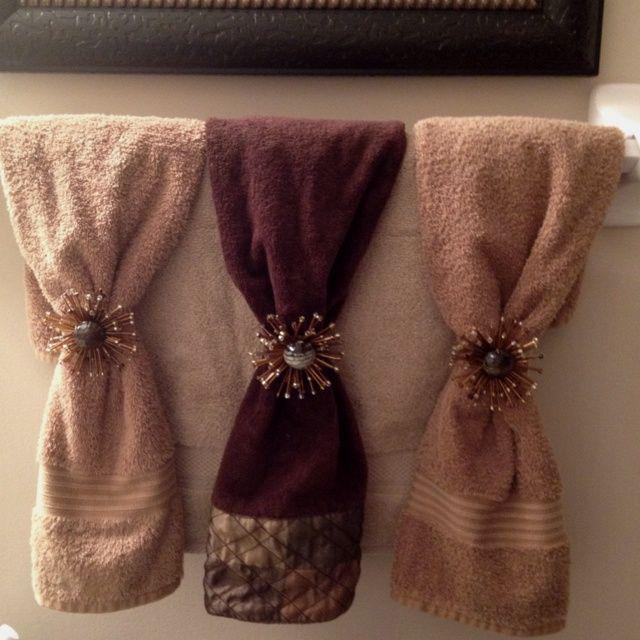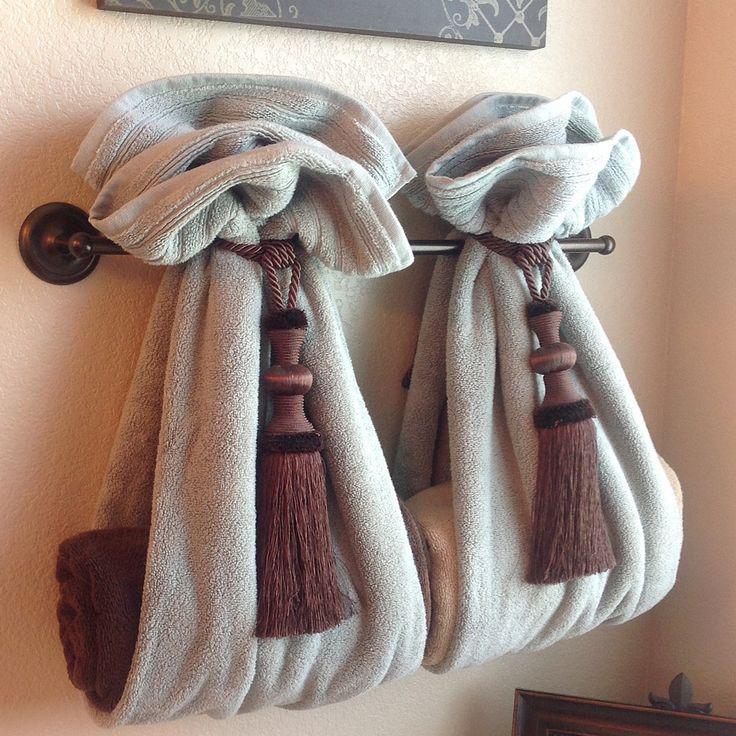The first image is the image on the left, the second image is the image on the right. Assess this claim about the two images: "Right image features side-by-side towels arranged decoratively on a bar.". Correct or not? Answer yes or no. Yes. The first image is the image on the left, the second image is the image on the right. Assess this claim about the two images: "A picture is hanging on the wall above some towels.". Correct or not? Answer yes or no. Yes. 